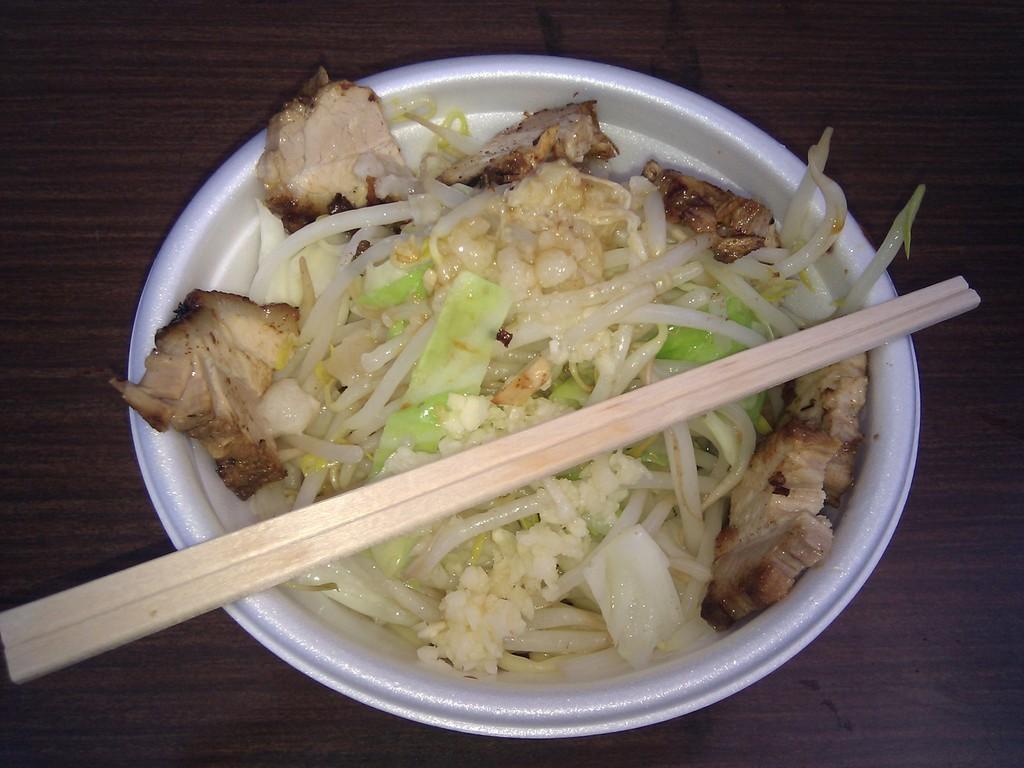Describe this image in one or two sentences. It is a closed picture of food item present in a white bowl and on the top there is stick. The white ball is placed on the wooden surface. 